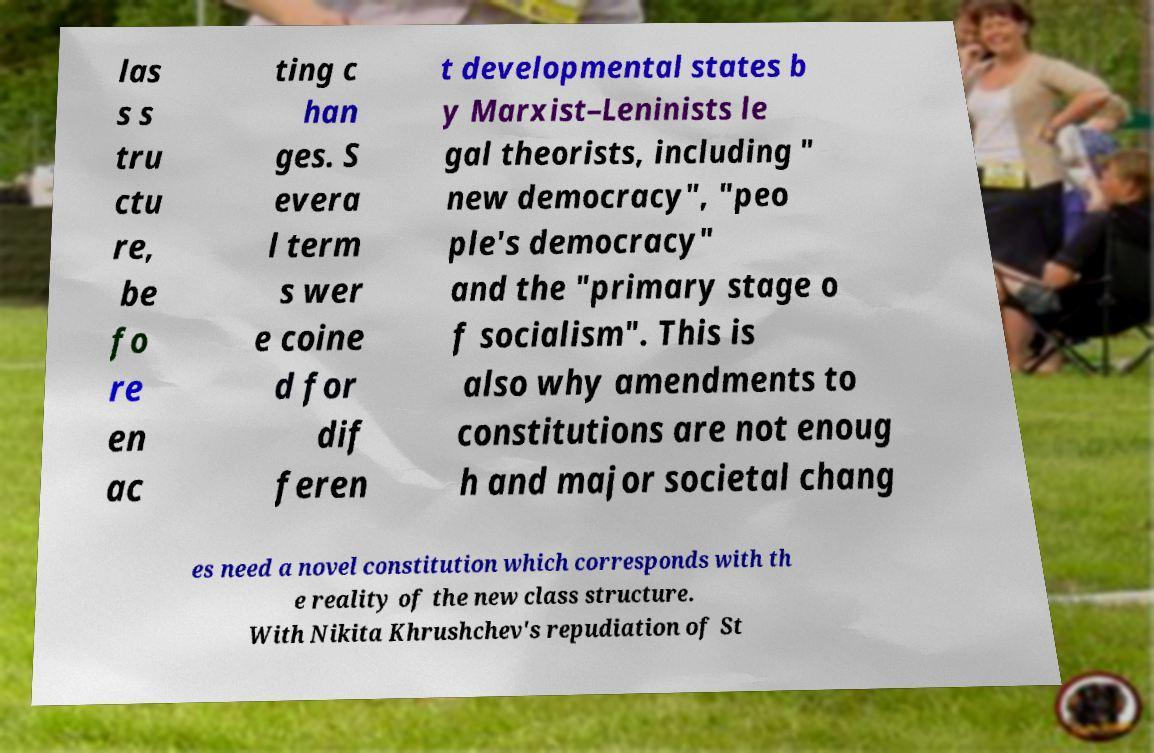What messages or text are displayed in this image? I need them in a readable, typed format. las s s tru ctu re, be fo re en ac ting c han ges. S evera l term s wer e coine d for dif feren t developmental states b y Marxist–Leninists le gal theorists, including " new democracy", "peo ple's democracy" and the "primary stage o f socialism". This is also why amendments to constitutions are not enoug h and major societal chang es need a novel constitution which corresponds with th e reality of the new class structure. With Nikita Khrushchev's repudiation of St 